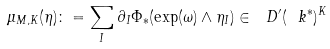<formula> <loc_0><loc_0><loc_500><loc_500>\mu _ { M , K } ( \eta ) \colon = \sum _ { I } \partial _ { I } \Phi _ { * } ( \exp ( \omega ) \wedge \eta _ { I } ) \in \ D ^ { \prime } ( \ k ^ { * } ) ^ { K }</formula> 